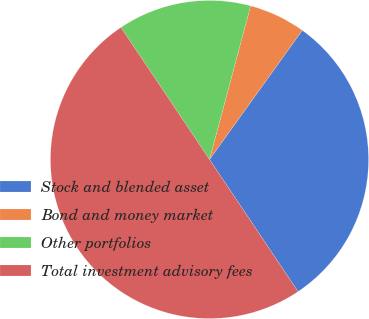Convert chart. <chart><loc_0><loc_0><loc_500><loc_500><pie_chart><fcel>Stock and blended asset<fcel>Bond and money market<fcel>Other portfolios<fcel>Total investment advisory fees<nl><fcel>30.69%<fcel>5.75%<fcel>13.56%<fcel>50.0%<nl></chart> 